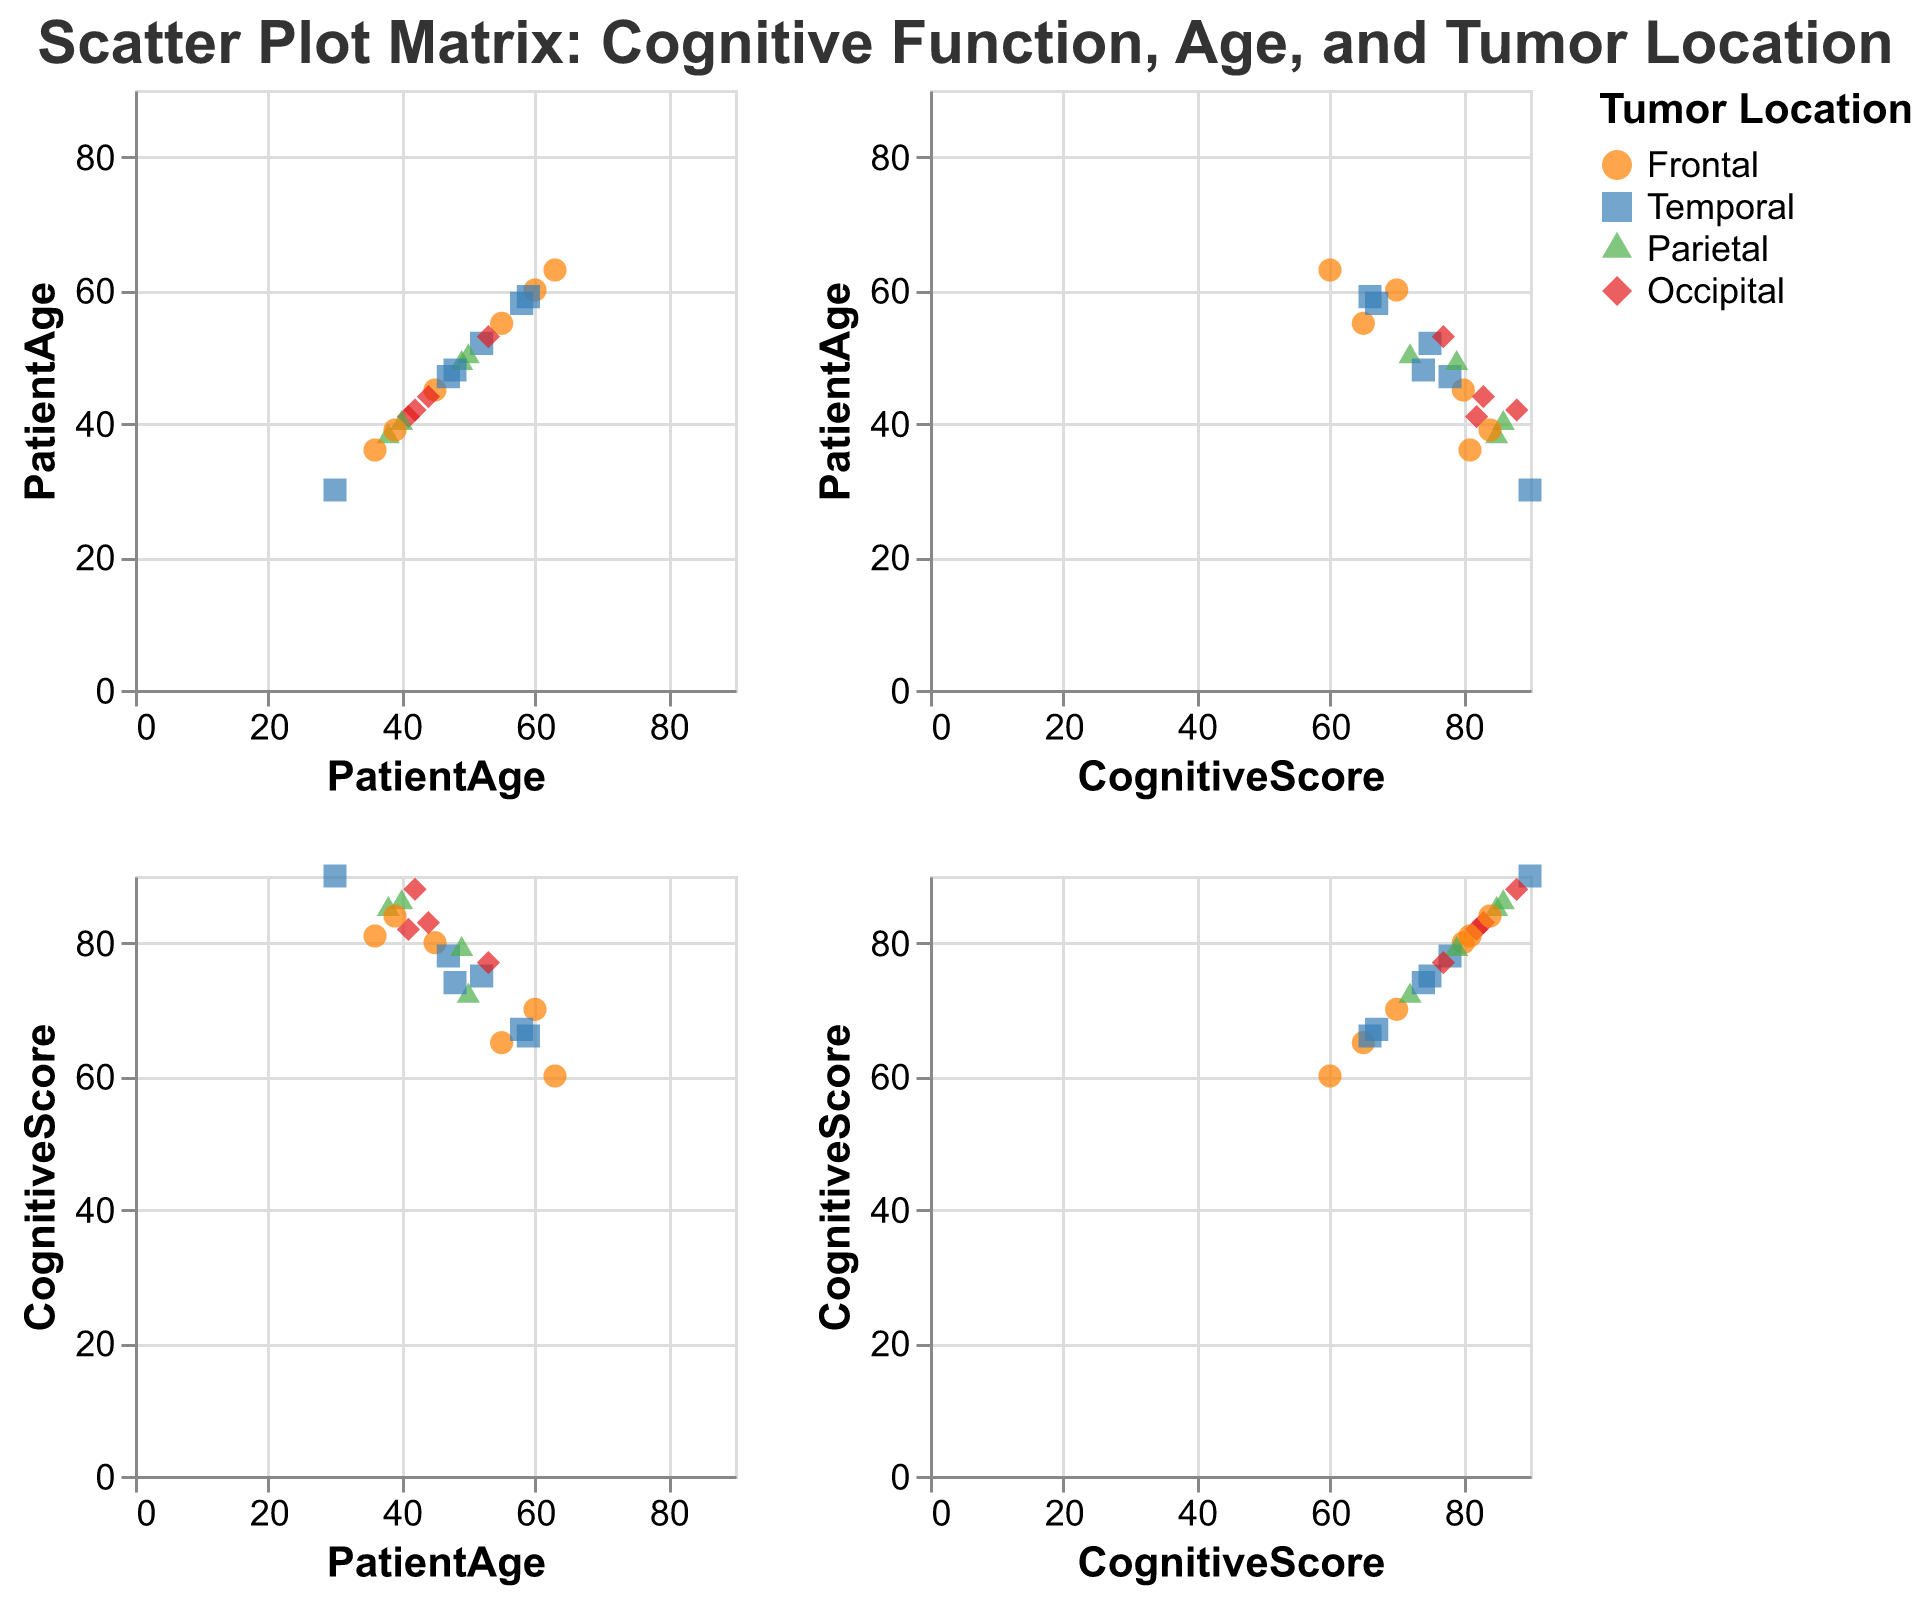What's the title of the figure? The title is found at the top of the figure and reads "Scatter Plot Matrix: Cognitive Function, Age, and Tumor Location."
Answer: Scatter Plot Matrix: Cognitive Function, Age, and Tumor Location What axis labels are used in the plot? Each axis is labeled either "PatientAge" or "CognitiveScore." These labels repeat across the matrix for both the x and y axes.
Answer: PatientAge, CognitiveScore How many different tumor locations are represented in the plot? The legend shows four different symbols and colors, corresponding to "Frontal," "Temporal," "Parietal," and "Occipital."
Answer: 4 Which tumor location has the highest cognitive score, and what is that score? The highest cognitive score is 90, and it belongs to a patient with a "Temporal" tumor location, indicated by the "Temporal" shape and color in the region of high cognitive scores.
Answer: Temporal, 90 What's the average cognitive score for patients with a 'Frontal' tumor location? Add the cognitive scores for all 'Frontal' tumor patients (80, 70, 65, 81, 60, 84): (80 + 70 + 65 + 81 + 60 + 84) = 440. Divide by the number of 'Frontal' patients (6): 440 / 6 = ~73.33.
Answer: ~73.33 Is there a noticeable trend between patient age and cognitive score? Observing the scatter plot cells for 'PatientAge' vs 'CognitiveScore,' points are scattered without a clear upward or downward trend, suggesting there is no strong correlation between age and cognitive score in this dataset.
Answer: No noticeable trend Which tumor locations are associated with the highest cognitive scores overall? The symbols for the highest cognitive scores cluster around certain shapes and colors: primarily 'Temporal' and 'Occipital,' as indicated by the scatter points.
Answer: Temporal, Occipital Are there more data points (patients) with 'Parietal' or 'Occipital' tumor locations? Count the different symbols for 'Parietal' triangles and 'Occipital' diamonds in the scatter plots. There are 4 'Parietal' and 4 'Occipital' patients, so the number is the same.
Answer: Same number (4) Which patient's cognitive score deviates the most from the average cognitive score for their tumor location? Calculate the average cognitive score for each tumor location and find the patient whose score deviates the most. For example, 'Frontal' average is ~73.33, and the biggest deviation among 'Frontal' patients is 60, deviating by ~13.33. Similarly, calculate for other locations and compare. Analyzing the set, patient 15 (Cognitive Score 60 with 'Frontal') is farthest from the average.
Answer: Patient 15 